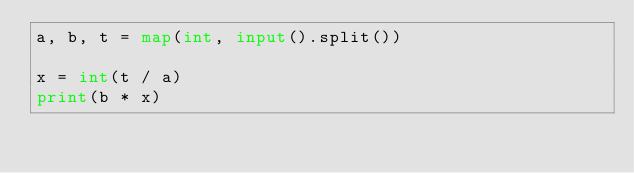Convert code to text. <code><loc_0><loc_0><loc_500><loc_500><_Python_>a, b, t = map(int, input().split())

x = int(t / a)
print(b * x)
</code> 